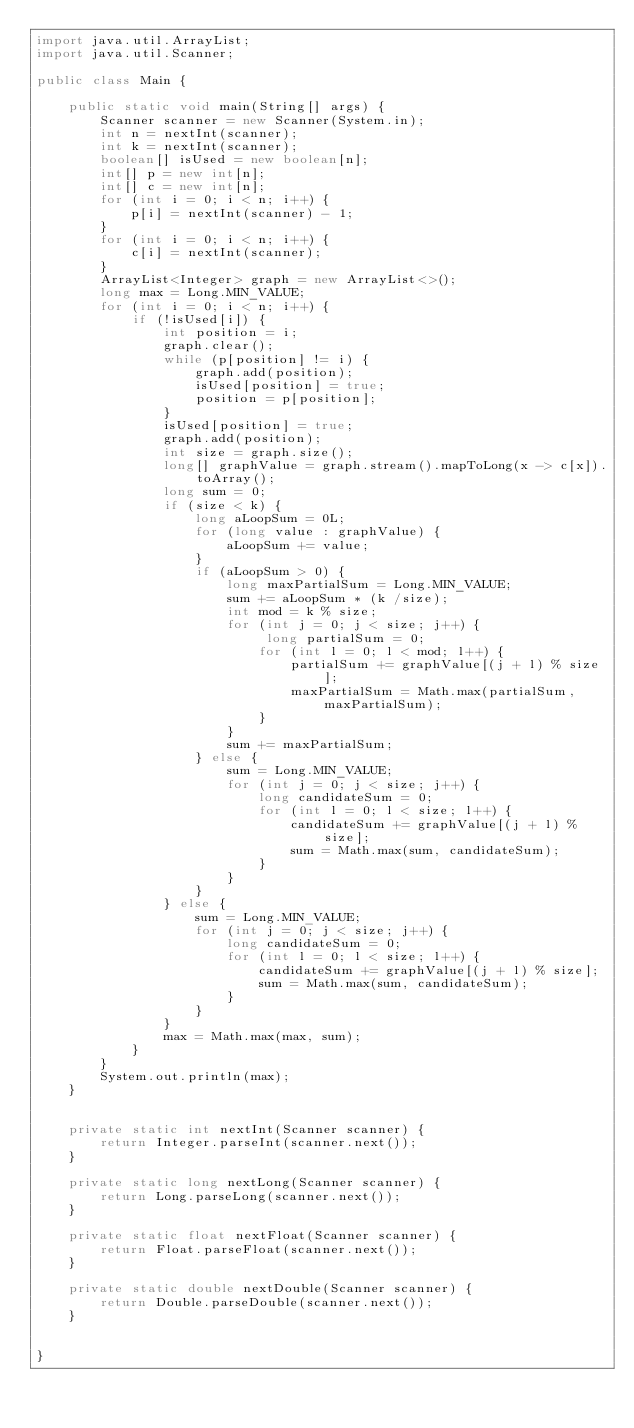Convert code to text. <code><loc_0><loc_0><loc_500><loc_500><_Java_>import java.util.ArrayList;
import java.util.Scanner;

public class Main {

    public static void main(String[] args) {
        Scanner scanner = new Scanner(System.in);
        int n = nextInt(scanner);
        int k = nextInt(scanner);
        boolean[] isUsed = new boolean[n];
        int[] p = new int[n];
        int[] c = new int[n];
        for (int i = 0; i < n; i++) {
            p[i] = nextInt(scanner) - 1;
        }
        for (int i = 0; i < n; i++) {
            c[i] = nextInt(scanner);
        }
        ArrayList<Integer> graph = new ArrayList<>();
        long max = Long.MIN_VALUE;
        for (int i = 0; i < n; i++) {
            if (!isUsed[i]) {
                int position = i;
                graph.clear();
                while (p[position] != i) {
                    graph.add(position);
                    isUsed[position] = true;
                    position = p[position];
                }
                isUsed[position] = true;
                graph.add(position);
                int size = graph.size();
                long[] graphValue = graph.stream().mapToLong(x -> c[x]).toArray();
                long sum = 0;
                if (size < k) {
                    long aLoopSum = 0L;
                    for (long value : graphValue) {
                        aLoopSum += value;
                    }
                    if (aLoopSum > 0) {
                        long maxPartialSum = Long.MIN_VALUE;
                        sum += aLoopSum * (k /size);
                        int mod = k % size;
                        for (int j = 0; j < size; j++) {
                             long partialSum = 0;
                            for (int l = 0; l < mod; l++) {
                                partialSum += graphValue[(j + l) % size];
                                maxPartialSum = Math.max(partialSum, maxPartialSum);
                            }
                        }
                        sum += maxPartialSum;
                    } else {
                        sum = Long.MIN_VALUE;
                        for (int j = 0; j < size; j++) {
                            long candidateSum = 0;
                            for (int l = 0; l < size; l++) {
                                candidateSum += graphValue[(j + l) % size];
                                sum = Math.max(sum, candidateSum);
                            }
                        }
                    }
                } else {
                    sum = Long.MIN_VALUE;
                    for (int j = 0; j < size; j++) {
                        long candidateSum = 0;
                        for (int l = 0; l < size; l++) {
                            candidateSum += graphValue[(j + l) % size];
                            sum = Math.max(sum, candidateSum);
                        }
                    }
                }
                max = Math.max(max, sum);
            }
        }
        System.out.println(max);
    }


    private static int nextInt(Scanner scanner) {
        return Integer.parseInt(scanner.next());
    }

    private static long nextLong(Scanner scanner) {
        return Long.parseLong(scanner.next());
    }

    private static float nextFloat(Scanner scanner) {
        return Float.parseFloat(scanner.next());
    }

    private static double nextDouble(Scanner scanner) {
        return Double.parseDouble(scanner.next());
    }


}







</code> 